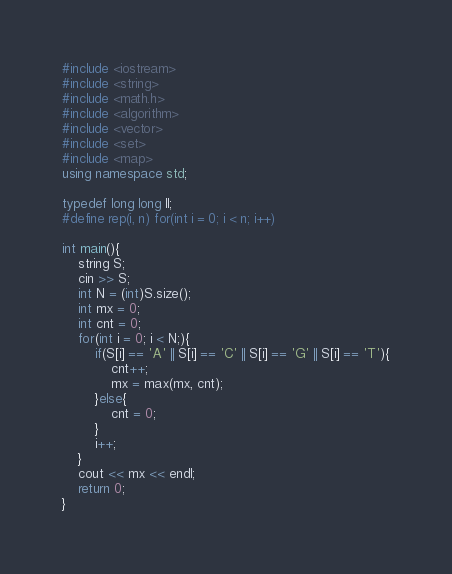<code> <loc_0><loc_0><loc_500><loc_500><_C++_>#include <iostream>
#include <string>
#include <math.h>
#include <algorithm>
#include <vector>
#include <set>
#include <map>
using namespace std;

typedef long long ll;
#define rep(i, n) for(int i = 0; i < n; i++)

int main(){
    string S;
    cin >> S;
    int N = (int)S.size();
    int mx = 0;
    int cnt = 0;
    for(int i = 0; i < N;){
        if(S[i] == 'A' || S[i] == 'C' || S[i] == 'G' || S[i] == 'T'){
            cnt++;
            mx = max(mx, cnt);
        }else{
            cnt = 0;
        }
        i++;
    }
    cout << mx << endl;
    return 0;
}</code> 